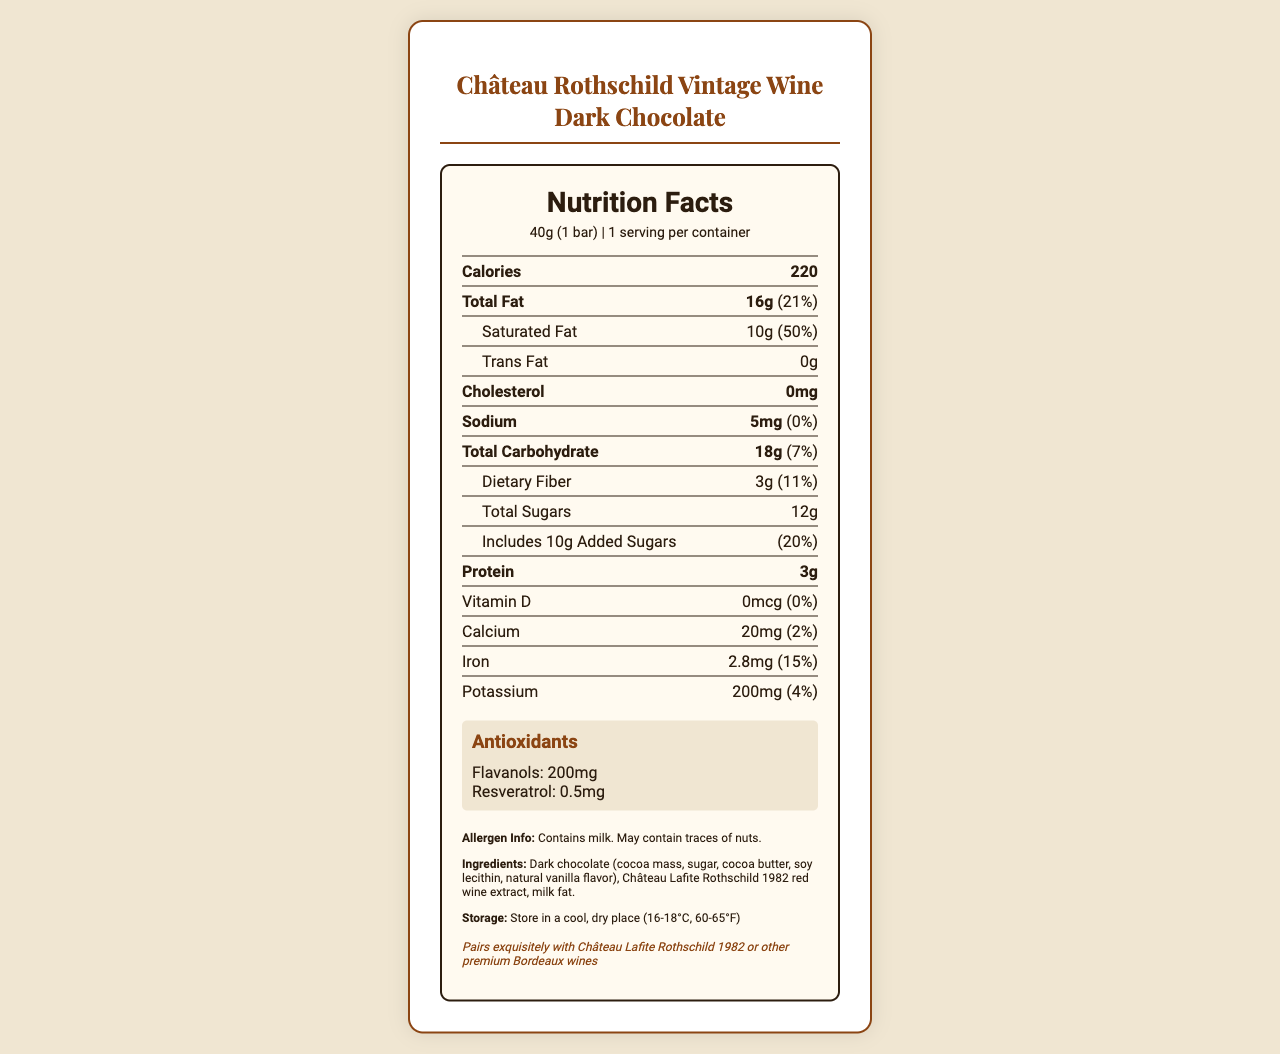what is the serving size? The serving size is shown at the top of the nutrition label as 40g (1 bar).
Answer: 40g (1 bar) How much calcium is in one serving? The document indicates that there is 20mg of calcium per serving.
Answer: 20mg What antioxidant is mentioned alongside flavanols? The antioxidants section lists flavanols and resveratrol.
Answer: Resveratrol What is the daily value percentage of saturated fat? The daily value percentage for saturated fat is shown as 50%.
Answer: 50% How many grams of total sugars does the chocolate bar have? The document specifies that there are 12g of total sugars.
Answer: 12g Which of the following best describes the antioxidant properties of this chocolate bar? A. High in Vitamin C B. Contains flavanols and resveratrol C. Contains omega-3 fatty acids D. High in fiber The antioxidants section mentions that the chocolate bar contains flavanols and resveratrol.
Answer: B What is the total fat content in one serving of this chocolate bar? A. 10g B. 16g C. 20g D. 18g The total fat content is listed as 16g.
Answer: B Does this chocolate bar contain any cholesterol? The document states that the chocolate bar contains 0mg of cholesterol.
Answer: No Can you summarize the main nutritional elements and features of Château Rothschild Vintage Wine Dark Chocolate as described? This summary covers the main nutritional elements, highlighting the serving size, macros, vitamins and minerals, and special features such as antioxidants and potential allergens.
Answer: The Château Rothschild Vintage Wine Dark Chocolate has a serving size of 40g and contains 220 calories. It has 16g of total fat, including 10g of saturated fat, and 18g of carbohydrates with 3g of dietary fiber and 12g of total sugars. It provides 3g of protein. Notable micronutrients include 20mg calcium, 2.8mg iron, and 200mg potassium. The chocolate bar is rich in antioxidants, specifically 200mg flavanols and 0.5mg resveratrol. It also contains milk and may have traces of nuts. How should the chocolate bar be stored? The storage instructions specify to store in a cool, dry place at 16-18°C (60-65°F).
Answer: In a cool, dry place (16-18°C, 60-65°F) Does this chocolate bar contain any allergens? It contains milk and may contain traces of nuts, as stated in the allergen information.
Answer: Yes What is the main idea of the additional info section? The additional information highlights the unique combination of high-quality ingredients and antioxidants, emphasizing its appeal to a specific target audience.
Answer: The chocolate bar combines 72% cocoa dark chocolate with vintage Château Lafite Rothschild wine, providing a perfect balance of flavors and antioxidants, and is crafted for a discerning palate. It is also ideal for automotive enthusiasts and wine connoisseurs. What type of extract is used in the ingredients? The ingredients list includes Château Lafite Rothschild 1982 red wine extract.
Answer: Château Lafite Rothschild 1982 red wine extract Is there any information on how the product packaging affects the environment? The packaging is eco-friendly and recyclable, as mentioned in the packaging section.
Answer: Yes What is the recommended wine pairing for this chocolate bar? The wine pairing suggestion recommends pairing the chocolate bar with Château Lafite Rothschild 1982 or other premium Bordeaux wines.
Answer: Château Lafite Rothschild 1982 or other premium Bordeaux wines What is the exact amount of added sugars in one serving? The document specifies that there are 10g of added sugars per serving.
Answer: 10g Who is the manufacturer of this chocolate bar? The manufacturer is listed as Rolls-Royce Gourmet Confections, London, UK.
Answer: Rolls-Royce Gourmet Confections, London, UK What is the product name displayed on the document? The product name at the top of the document is Château Rothschild Vintage Wine Dark Chocolate.
Answer: Château Rothschild Vintage Wine Dark Chocolate What is the percentage daily value of dietary fiber in one serving? The document lists the daily value percentage for dietary fiber as 11%.
Answer: 11% What is the total carbohydrate content of the chocolate bar? The total carbohydrate content is listed as 18g.
Answer: 18g Has this chocolate bar  been crafted for a specific audience? If so, who? The additional information states that it is crafted for discerning palates, specifically automotive enthusiasts and wine connoisseurs.
Answer: Yes, it is ideal for automotive enthusiasts and wine connoisseurs. When was the chocolate bar manufactured? The document does not provide any manufacturing date.
Answer: Not enough information 